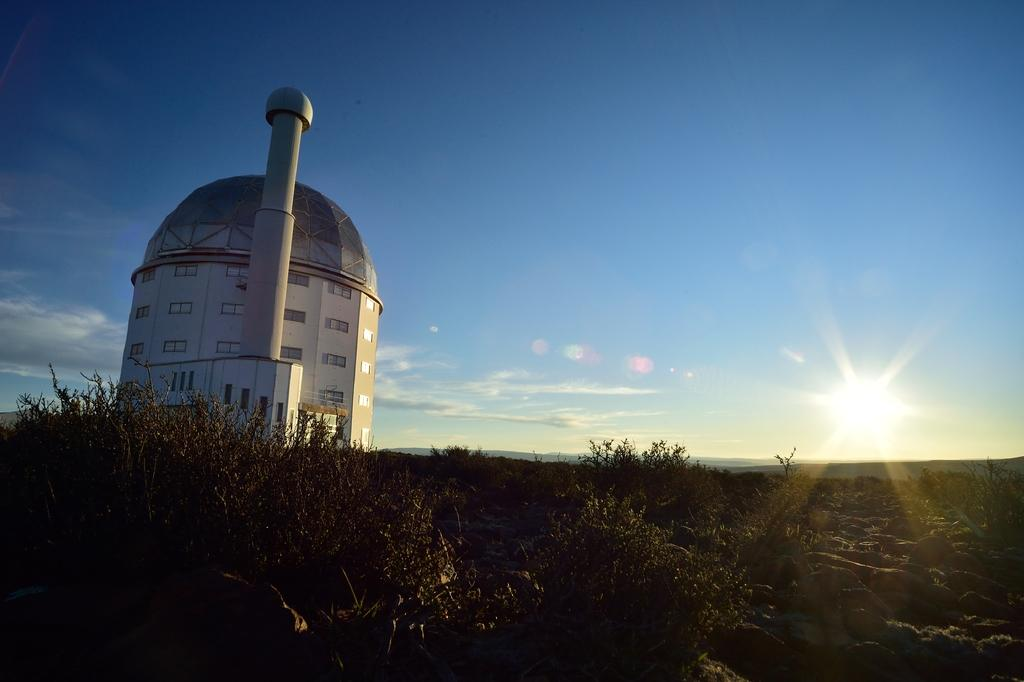What structure is located on the left side of the image? There is a building on the left side of the image. What feature can be observed on the building? The building has glass windows. What type of vegetation is present in the image? There are plants in the image. How would you describe the weather based on the sky in the image? The sky is clear and sunny in the image. What type of milk can be seen being poured in the image? There is no milk present in the image. What sound can be heard coming from the building in the image? There is no sound present in the image, as it is a still photograph. 